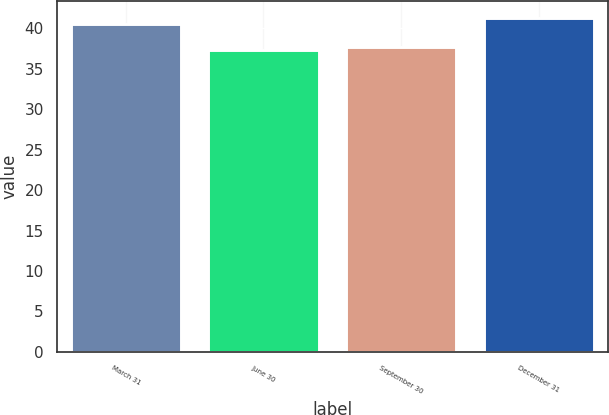Convert chart. <chart><loc_0><loc_0><loc_500><loc_500><bar_chart><fcel>March 31<fcel>June 30<fcel>September 30<fcel>December 31<nl><fcel>40.51<fcel>37.26<fcel>37.67<fcel>41.33<nl></chart> 